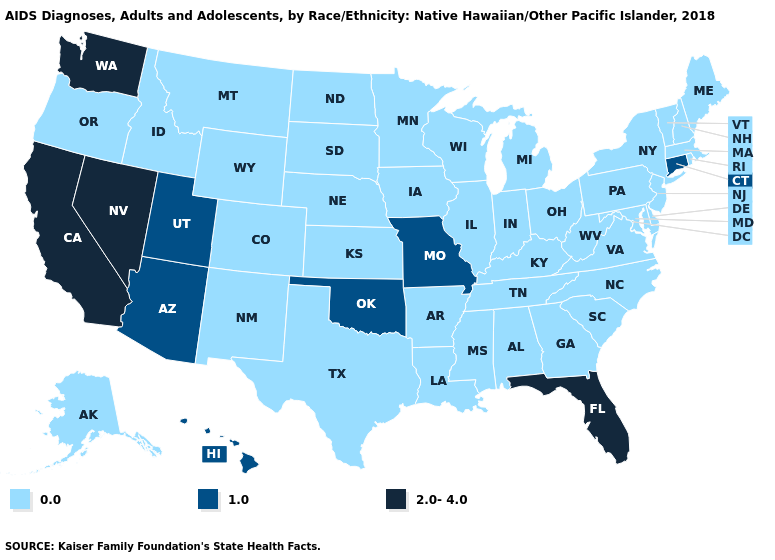What is the value of New Hampshire?
Answer briefly. 0.0. Name the states that have a value in the range 2.0-4.0?
Keep it brief. California, Florida, Nevada, Washington. Name the states that have a value in the range 0.0?
Write a very short answer. Alabama, Alaska, Arkansas, Colorado, Delaware, Georgia, Idaho, Illinois, Indiana, Iowa, Kansas, Kentucky, Louisiana, Maine, Maryland, Massachusetts, Michigan, Minnesota, Mississippi, Montana, Nebraska, New Hampshire, New Jersey, New Mexico, New York, North Carolina, North Dakota, Ohio, Oregon, Pennsylvania, Rhode Island, South Carolina, South Dakota, Tennessee, Texas, Vermont, Virginia, West Virginia, Wisconsin, Wyoming. What is the value of Maine?
Be succinct. 0.0. Name the states that have a value in the range 1.0?
Quick response, please. Arizona, Connecticut, Hawaii, Missouri, Oklahoma, Utah. What is the value of Massachusetts?
Answer briefly. 0.0. Name the states that have a value in the range 1.0?
Short answer required. Arizona, Connecticut, Hawaii, Missouri, Oklahoma, Utah. What is the value of Florida?
Quick response, please. 2.0-4.0. What is the value of New Jersey?
Be succinct. 0.0. Which states hav the highest value in the Northeast?
Quick response, please. Connecticut. What is the value of Massachusetts?
Keep it brief. 0.0. Does Arizona have a lower value than Alabama?
Keep it brief. No. What is the value of Kentucky?
Be succinct. 0.0. Does New Hampshire have a lower value than Arkansas?
Quick response, please. No. 